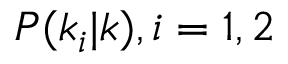<formula> <loc_0><loc_0><loc_500><loc_500>P ( k _ { i } | k ) , i = 1 , 2</formula> 